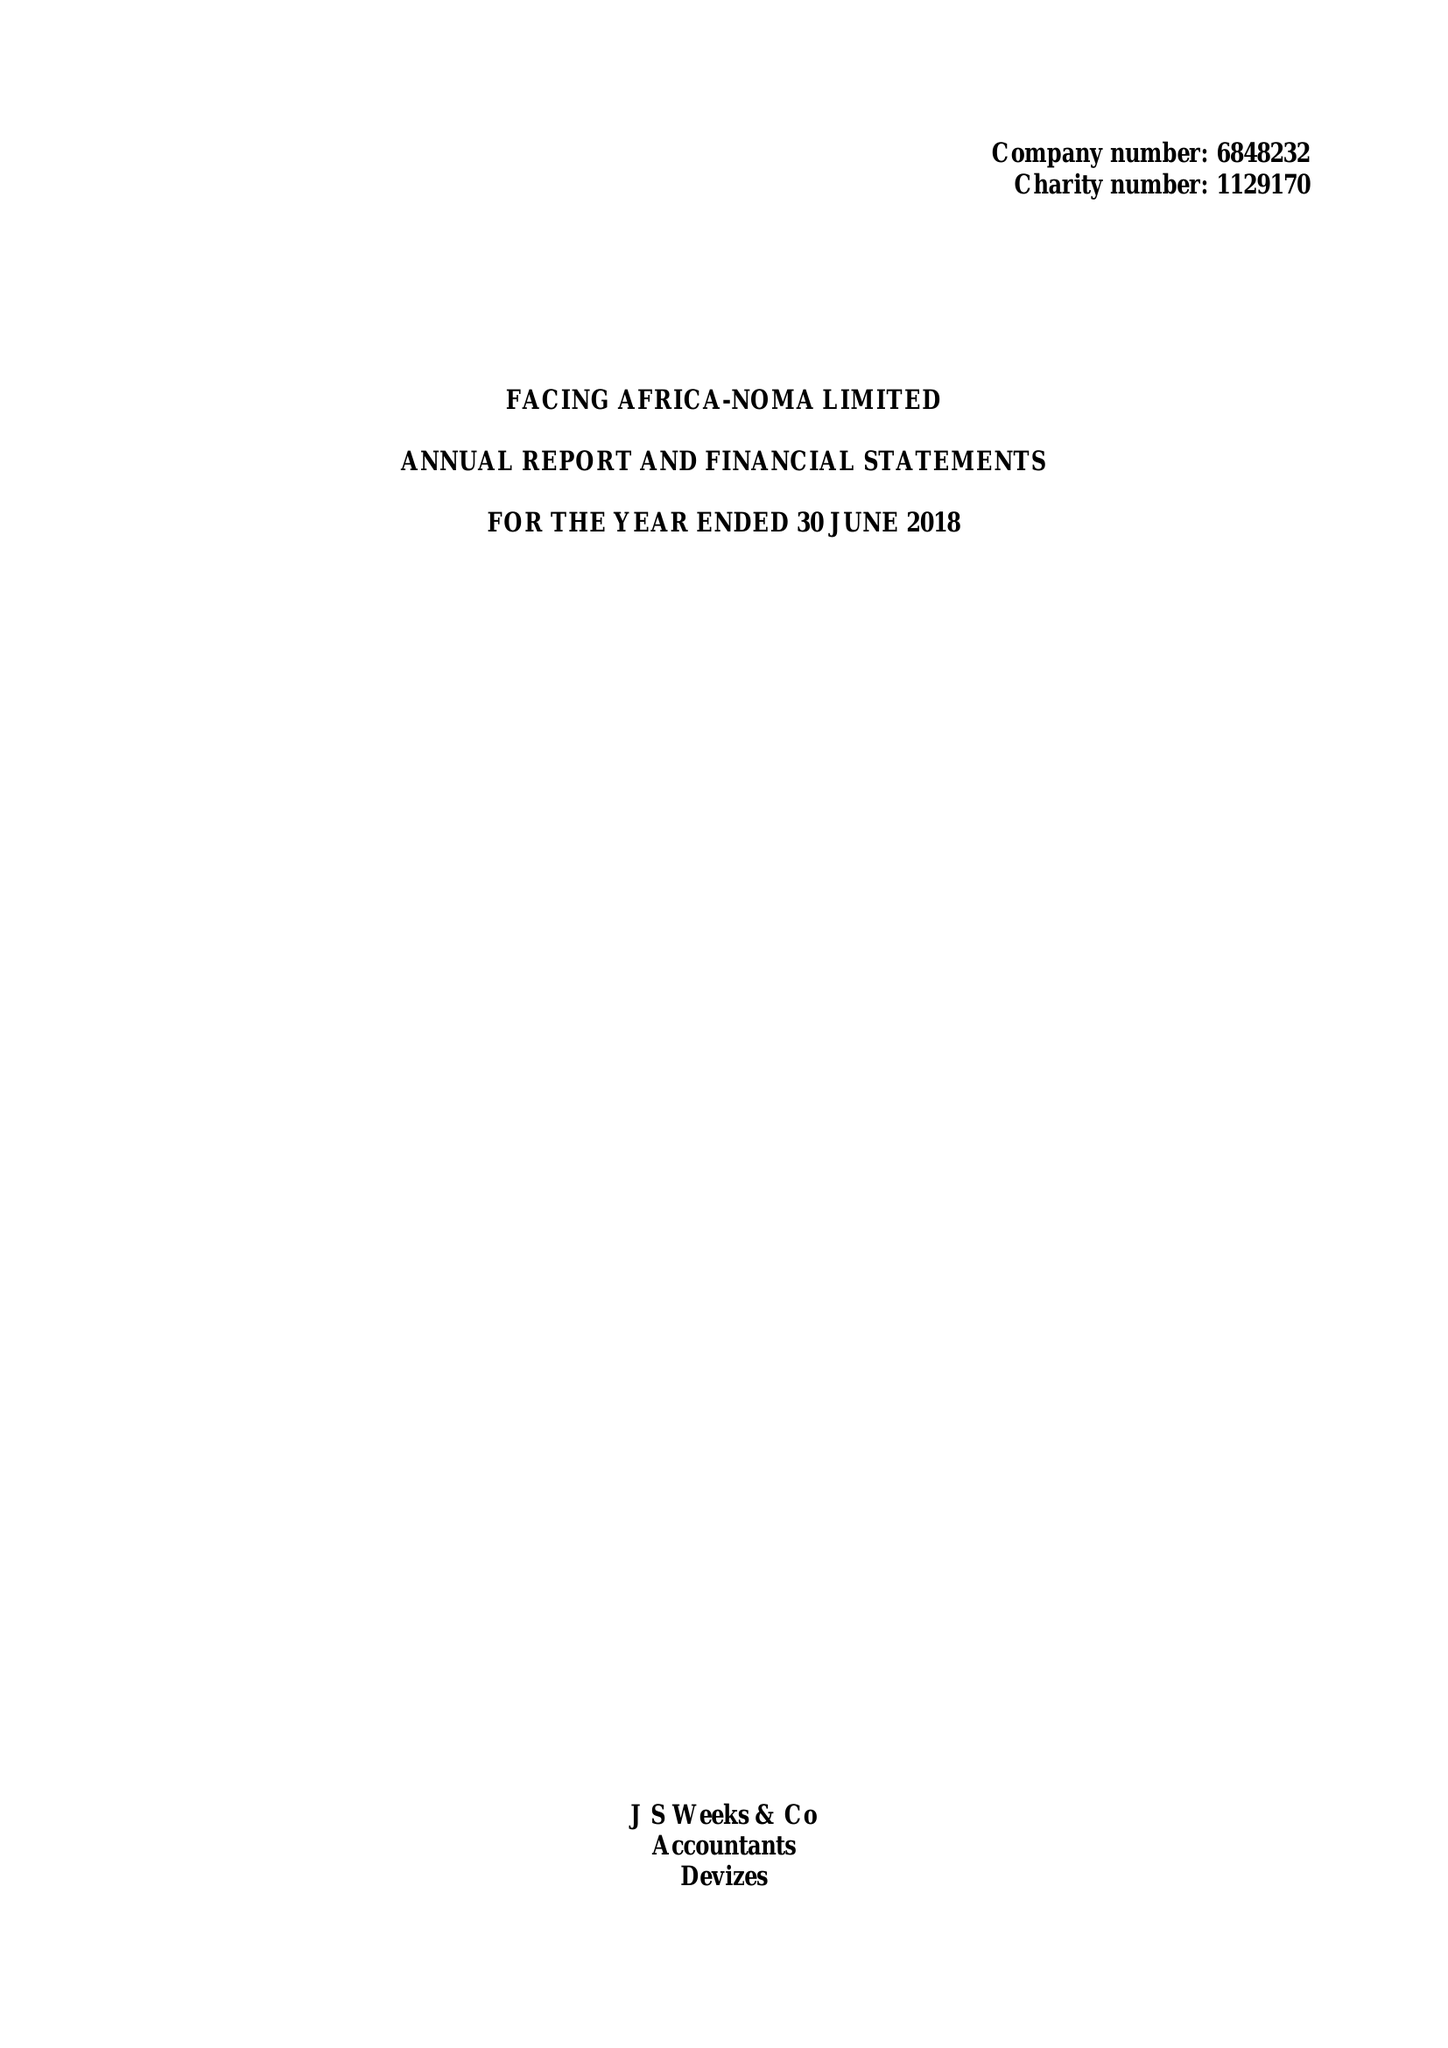What is the value for the spending_annually_in_british_pounds?
Answer the question using a single word or phrase. 207324.00 